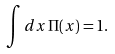Convert formula to latex. <formula><loc_0><loc_0><loc_500><loc_500>\int d x \, \Pi ( x ) = 1 .</formula> 